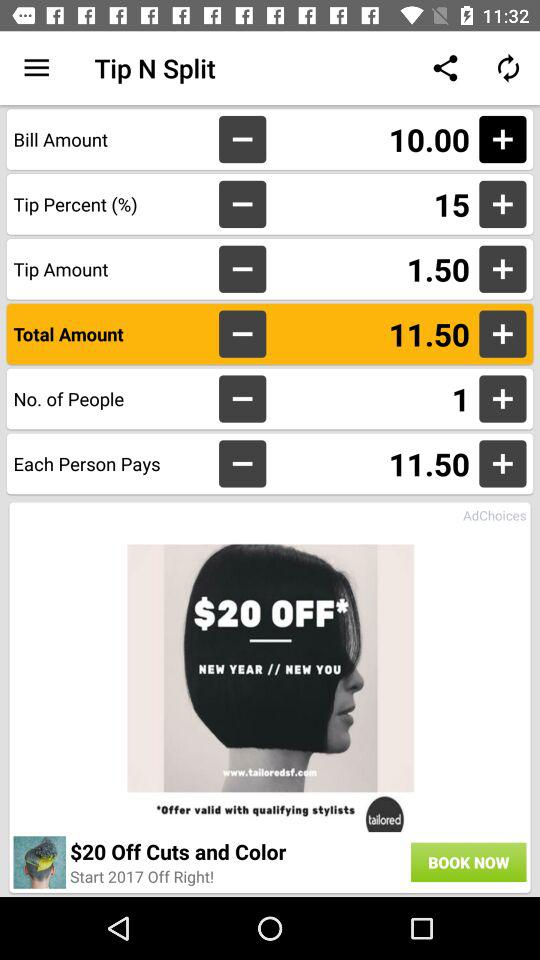What is the amount each person has to pay? Each person has to pay the amount of 11.50. 